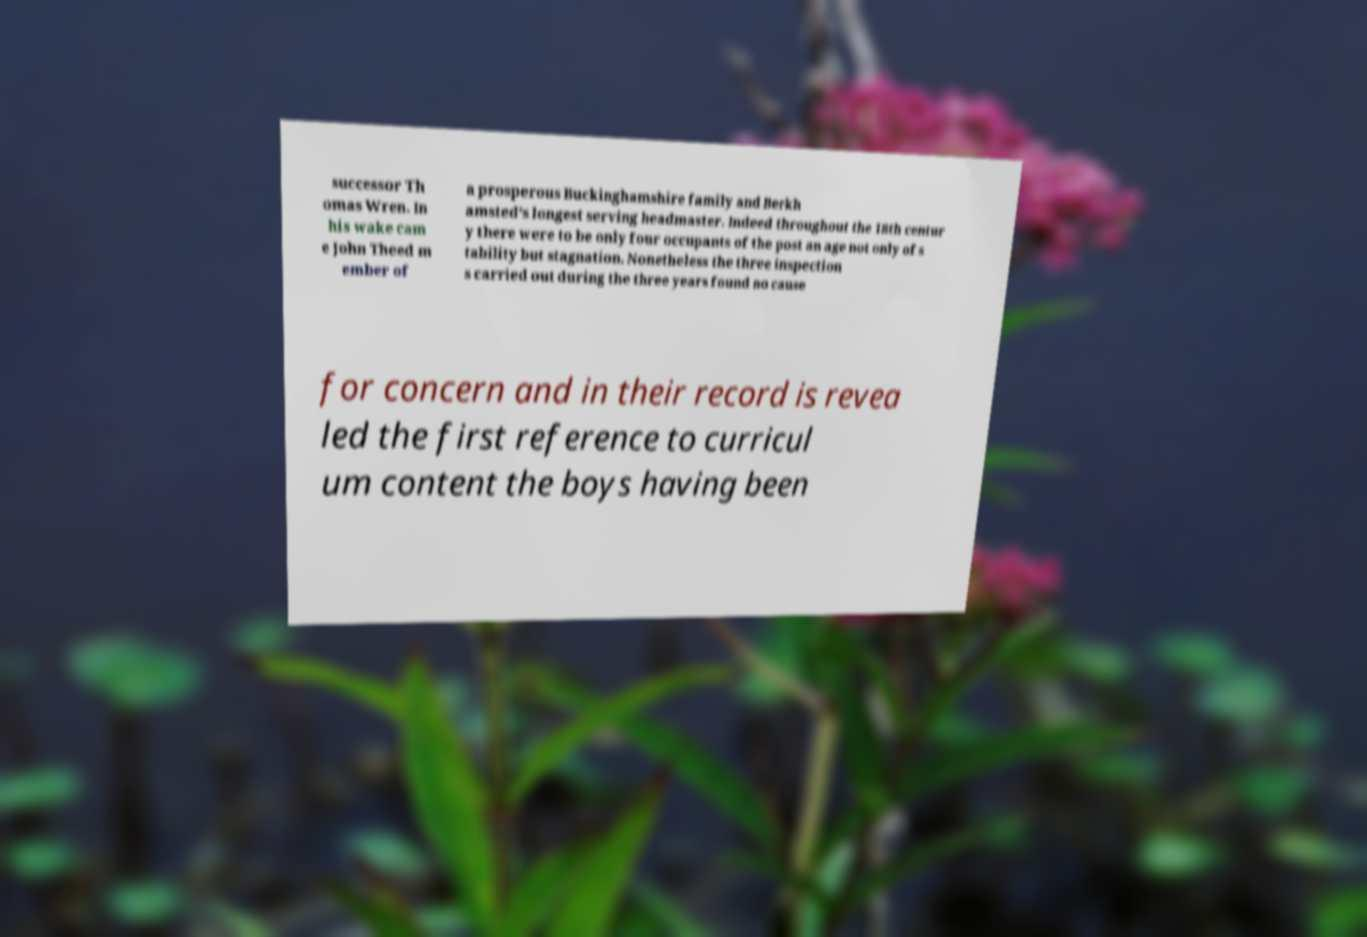I need the written content from this picture converted into text. Can you do that? successor Th omas Wren. In his wake cam e John Theed m ember of a prosperous Buckinghamshire family and Berkh amsted's longest serving headmaster. Indeed throughout the 18th centur y there were to be only four occupants of the post an age not only of s tability but stagnation. Nonetheless the three inspection s carried out during the three years found no cause for concern and in their record is revea led the first reference to curricul um content the boys having been 